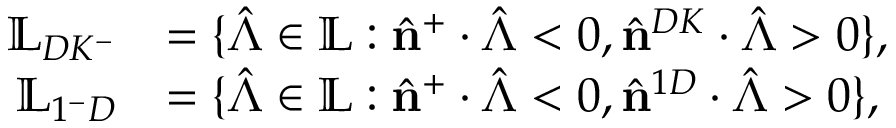<formula> <loc_0><loc_0><loc_500><loc_500>\begin{array} { r l } { \mathbb { L } _ { D K ^ { - } } } & { = \{ \hat { \Lambda } \in \mathbb { L } \colon \hat { n } ^ { + } \cdot \hat { \Lambda } < 0 , \hat { n } ^ { D K } \cdot \hat { \Lambda } > 0 \} , } \\ { \mathbb { L } _ { 1 ^ { - } D } } & { = \{ \hat { \Lambda } \in \mathbb { L } \colon \hat { n } ^ { + } \cdot \hat { \Lambda } < 0 , \hat { n } ^ { 1 D } \cdot \hat { \Lambda } > 0 \} , } \end{array}</formula> 